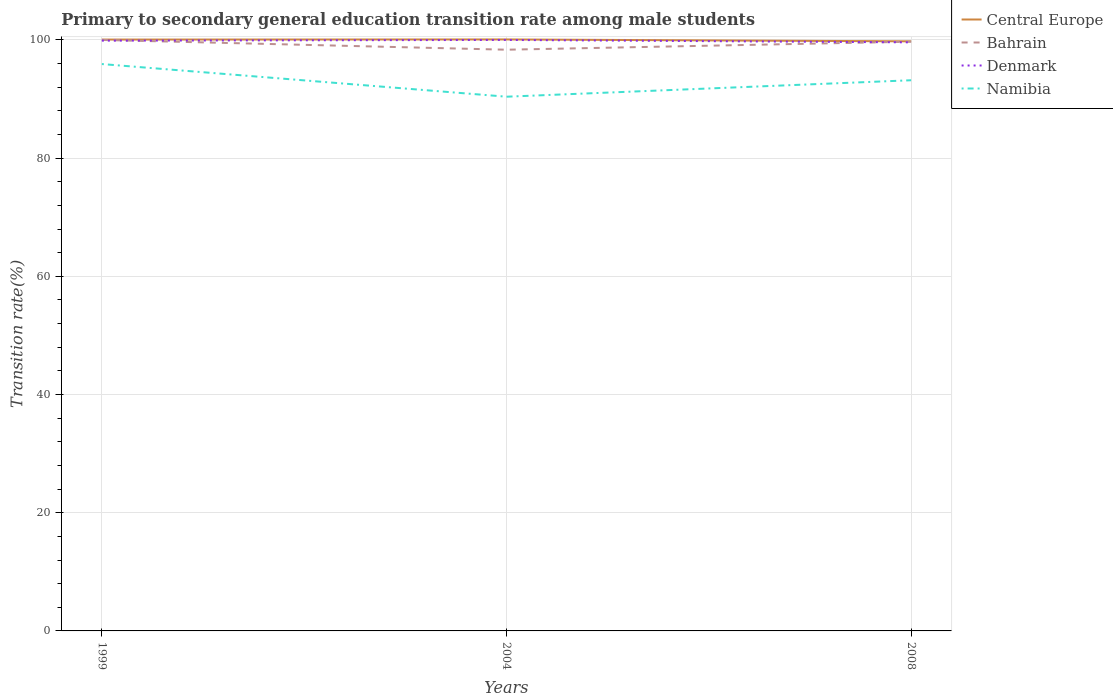How many different coloured lines are there?
Ensure brevity in your answer.  4. Does the line corresponding to Namibia intersect with the line corresponding to Central Europe?
Your response must be concise. No. Is the number of lines equal to the number of legend labels?
Offer a very short reply. Yes. Across all years, what is the maximum transition rate in Bahrain?
Ensure brevity in your answer.  98.35. In which year was the transition rate in Bahrain maximum?
Your answer should be very brief. 2004. What is the total transition rate in Namibia in the graph?
Provide a succinct answer. -2.78. What is the difference between the highest and the second highest transition rate in Denmark?
Offer a terse response. 0.41. How many years are there in the graph?
Give a very brief answer. 3. What is the difference between two consecutive major ticks on the Y-axis?
Offer a very short reply. 20. Are the values on the major ticks of Y-axis written in scientific E-notation?
Give a very brief answer. No. Does the graph contain any zero values?
Offer a terse response. No. How many legend labels are there?
Ensure brevity in your answer.  4. How are the legend labels stacked?
Provide a short and direct response. Vertical. What is the title of the graph?
Your response must be concise. Primary to secondary general education transition rate among male students. What is the label or title of the Y-axis?
Ensure brevity in your answer.  Transition rate(%). What is the Transition rate(%) in Central Europe in 1999?
Your answer should be compact. 100.06. What is the Transition rate(%) of Bahrain in 1999?
Provide a succinct answer. 100. What is the Transition rate(%) of Denmark in 1999?
Your answer should be compact. 99.88. What is the Transition rate(%) of Namibia in 1999?
Your response must be concise. 95.92. What is the Transition rate(%) in Central Europe in 2004?
Your answer should be compact. 100.08. What is the Transition rate(%) of Bahrain in 2004?
Give a very brief answer. 98.35. What is the Transition rate(%) in Namibia in 2004?
Give a very brief answer. 90.39. What is the Transition rate(%) in Central Europe in 2008?
Keep it short and to the point. 99.76. What is the Transition rate(%) of Bahrain in 2008?
Your answer should be compact. 99.71. What is the Transition rate(%) in Denmark in 2008?
Your answer should be very brief. 99.59. What is the Transition rate(%) of Namibia in 2008?
Make the answer very short. 93.18. Across all years, what is the maximum Transition rate(%) in Central Europe?
Your response must be concise. 100.08. Across all years, what is the maximum Transition rate(%) of Namibia?
Offer a terse response. 95.92. Across all years, what is the minimum Transition rate(%) in Central Europe?
Provide a succinct answer. 99.76. Across all years, what is the minimum Transition rate(%) in Bahrain?
Ensure brevity in your answer.  98.35. Across all years, what is the minimum Transition rate(%) in Denmark?
Your answer should be very brief. 99.59. Across all years, what is the minimum Transition rate(%) in Namibia?
Keep it short and to the point. 90.39. What is the total Transition rate(%) of Central Europe in the graph?
Ensure brevity in your answer.  299.91. What is the total Transition rate(%) of Bahrain in the graph?
Offer a very short reply. 298.05. What is the total Transition rate(%) of Denmark in the graph?
Provide a succinct answer. 299.47. What is the total Transition rate(%) in Namibia in the graph?
Your answer should be compact. 279.49. What is the difference between the Transition rate(%) of Central Europe in 1999 and that in 2004?
Offer a terse response. -0.02. What is the difference between the Transition rate(%) of Bahrain in 1999 and that in 2004?
Give a very brief answer. 1.65. What is the difference between the Transition rate(%) in Denmark in 1999 and that in 2004?
Offer a terse response. -0.12. What is the difference between the Transition rate(%) of Namibia in 1999 and that in 2004?
Keep it short and to the point. 5.52. What is the difference between the Transition rate(%) of Central Europe in 1999 and that in 2008?
Your response must be concise. 0.3. What is the difference between the Transition rate(%) of Bahrain in 1999 and that in 2008?
Keep it short and to the point. 0.29. What is the difference between the Transition rate(%) of Denmark in 1999 and that in 2008?
Your answer should be compact. 0.29. What is the difference between the Transition rate(%) in Namibia in 1999 and that in 2008?
Offer a terse response. 2.74. What is the difference between the Transition rate(%) of Central Europe in 2004 and that in 2008?
Your response must be concise. 0.32. What is the difference between the Transition rate(%) in Bahrain in 2004 and that in 2008?
Keep it short and to the point. -1.36. What is the difference between the Transition rate(%) of Denmark in 2004 and that in 2008?
Offer a terse response. 0.41. What is the difference between the Transition rate(%) of Namibia in 2004 and that in 2008?
Keep it short and to the point. -2.78. What is the difference between the Transition rate(%) of Central Europe in 1999 and the Transition rate(%) of Bahrain in 2004?
Offer a very short reply. 1.72. What is the difference between the Transition rate(%) in Central Europe in 1999 and the Transition rate(%) in Denmark in 2004?
Offer a very short reply. 0.06. What is the difference between the Transition rate(%) of Central Europe in 1999 and the Transition rate(%) of Namibia in 2004?
Your answer should be compact. 9.67. What is the difference between the Transition rate(%) in Bahrain in 1999 and the Transition rate(%) in Denmark in 2004?
Offer a terse response. 0. What is the difference between the Transition rate(%) in Bahrain in 1999 and the Transition rate(%) in Namibia in 2004?
Provide a short and direct response. 9.61. What is the difference between the Transition rate(%) in Denmark in 1999 and the Transition rate(%) in Namibia in 2004?
Provide a short and direct response. 9.49. What is the difference between the Transition rate(%) in Central Europe in 1999 and the Transition rate(%) in Bahrain in 2008?
Provide a succinct answer. 0.36. What is the difference between the Transition rate(%) in Central Europe in 1999 and the Transition rate(%) in Denmark in 2008?
Offer a very short reply. 0.47. What is the difference between the Transition rate(%) in Central Europe in 1999 and the Transition rate(%) in Namibia in 2008?
Ensure brevity in your answer.  6.88. What is the difference between the Transition rate(%) in Bahrain in 1999 and the Transition rate(%) in Denmark in 2008?
Offer a very short reply. 0.41. What is the difference between the Transition rate(%) of Bahrain in 1999 and the Transition rate(%) of Namibia in 2008?
Provide a succinct answer. 6.82. What is the difference between the Transition rate(%) in Denmark in 1999 and the Transition rate(%) in Namibia in 2008?
Offer a very short reply. 6.7. What is the difference between the Transition rate(%) of Central Europe in 2004 and the Transition rate(%) of Bahrain in 2008?
Your answer should be very brief. 0.38. What is the difference between the Transition rate(%) of Central Europe in 2004 and the Transition rate(%) of Denmark in 2008?
Your answer should be compact. 0.49. What is the difference between the Transition rate(%) in Central Europe in 2004 and the Transition rate(%) in Namibia in 2008?
Make the answer very short. 6.91. What is the difference between the Transition rate(%) of Bahrain in 2004 and the Transition rate(%) of Denmark in 2008?
Provide a short and direct response. -1.25. What is the difference between the Transition rate(%) of Bahrain in 2004 and the Transition rate(%) of Namibia in 2008?
Offer a terse response. 5.17. What is the difference between the Transition rate(%) in Denmark in 2004 and the Transition rate(%) in Namibia in 2008?
Give a very brief answer. 6.82. What is the average Transition rate(%) of Central Europe per year?
Provide a short and direct response. 99.97. What is the average Transition rate(%) of Bahrain per year?
Your answer should be compact. 99.35. What is the average Transition rate(%) of Denmark per year?
Offer a terse response. 99.82. What is the average Transition rate(%) of Namibia per year?
Your response must be concise. 93.16. In the year 1999, what is the difference between the Transition rate(%) of Central Europe and Transition rate(%) of Bahrain?
Ensure brevity in your answer.  0.06. In the year 1999, what is the difference between the Transition rate(%) in Central Europe and Transition rate(%) in Denmark?
Your answer should be compact. 0.18. In the year 1999, what is the difference between the Transition rate(%) in Central Europe and Transition rate(%) in Namibia?
Provide a short and direct response. 4.14. In the year 1999, what is the difference between the Transition rate(%) in Bahrain and Transition rate(%) in Denmark?
Your answer should be very brief. 0.12. In the year 1999, what is the difference between the Transition rate(%) of Bahrain and Transition rate(%) of Namibia?
Provide a short and direct response. 4.08. In the year 1999, what is the difference between the Transition rate(%) in Denmark and Transition rate(%) in Namibia?
Ensure brevity in your answer.  3.96. In the year 2004, what is the difference between the Transition rate(%) in Central Europe and Transition rate(%) in Bahrain?
Provide a short and direct response. 1.74. In the year 2004, what is the difference between the Transition rate(%) in Central Europe and Transition rate(%) in Denmark?
Make the answer very short. 0.08. In the year 2004, what is the difference between the Transition rate(%) of Central Europe and Transition rate(%) of Namibia?
Provide a short and direct response. 9.69. In the year 2004, what is the difference between the Transition rate(%) in Bahrain and Transition rate(%) in Denmark?
Ensure brevity in your answer.  -1.65. In the year 2004, what is the difference between the Transition rate(%) of Bahrain and Transition rate(%) of Namibia?
Your answer should be compact. 7.95. In the year 2004, what is the difference between the Transition rate(%) in Denmark and Transition rate(%) in Namibia?
Provide a succinct answer. 9.61. In the year 2008, what is the difference between the Transition rate(%) in Central Europe and Transition rate(%) in Bahrain?
Offer a very short reply. 0.06. In the year 2008, what is the difference between the Transition rate(%) in Central Europe and Transition rate(%) in Denmark?
Your answer should be compact. 0.17. In the year 2008, what is the difference between the Transition rate(%) of Central Europe and Transition rate(%) of Namibia?
Keep it short and to the point. 6.58. In the year 2008, what is the difference between the Transition rate(%) in Bahrain and Transition rate(%) in Denmark?
Offer a terse response. 0.11. In the year 2008, what is the difference between the Transition rate(%) of Bahrain and Transition rate(%) of Namibia?
Provide a succinct answer. 6.53. In the year 2008, what is the difference between the Transition rate(%) in Denmark and Transition rate(%) in Namibia?
Offer a very short reply. 6.41. What is the ratio of the Transition rate(%) of Bahrain in 1999 to that in 2004?
Make the answer very short. 1.02. What is the ratio of the Transition rate(%) in Denmark in 1999 to that in 2004?
Ensure brevity in your answer.  1. What is the ratio of the Transition rate(%) in Namibia in 1999 to that in 2004?
Your answer should be compact. 1.06. What is the ratio of the Transition rate(%) of Central Europe in 1999 to that in 2008?
Your response must be concise. 1. What is the ratio of the Transition rate(%) of Bahrain in 1999 to that in 2008?
Give a very brief answer. 1. What is the ratio of the Transition rate(%) in Namibia in 1999 to that in 2008?
Ensure brevity in your answer.  1.03. What is the ratio of the Transition rate(%) in Central Europe in 2004 to that in 2008?
Offer a very short reply. 1. What is the ratio of the Transition rate(%) in Bahrain in 2004 to that in 2008?
Keep it short and to the point. 0.99. What is the ratio of the Transition rate(%) in Denmark in 2004 to that in 2008?
Your response must be concise. 1. What is the ratio of the Transition rate(%) of Namibia in 2004 to that in 2008?
Make the answer very short. 0.97. What is the difference between the highest and the second highest Transition rate(%) in Central Europe?
Make the answer very short. 0.02. What is the difference between the highest and the second highest Transition rate(%) in Bahrain?
Keep it short and to the point. 0.29. What is the difference between the highest and the second highest Transition rate(%) of Denmark?
Make the answer very short. 0.12. What is the difference between the highest and the second highest Transition rate(%) of Namibia?
Offer a very short reply. 2.74. What is the difference between the highest and the lowest Transition rate(%) of Central Europe?
Ensure brevity in your answer.  0.32. What is the difference between the highest and the lowest Transition rate(%) of Bahrain?
Your answer should be very brief. 1.65. What is the difference between the highest and the lowest Transition rate(%) in Denmark?
Give a very brief answer. 0.41. What is the difference between the highest and the lowest Transition rate(%) of Namibia?
Offer a very short reply. 5.52. 